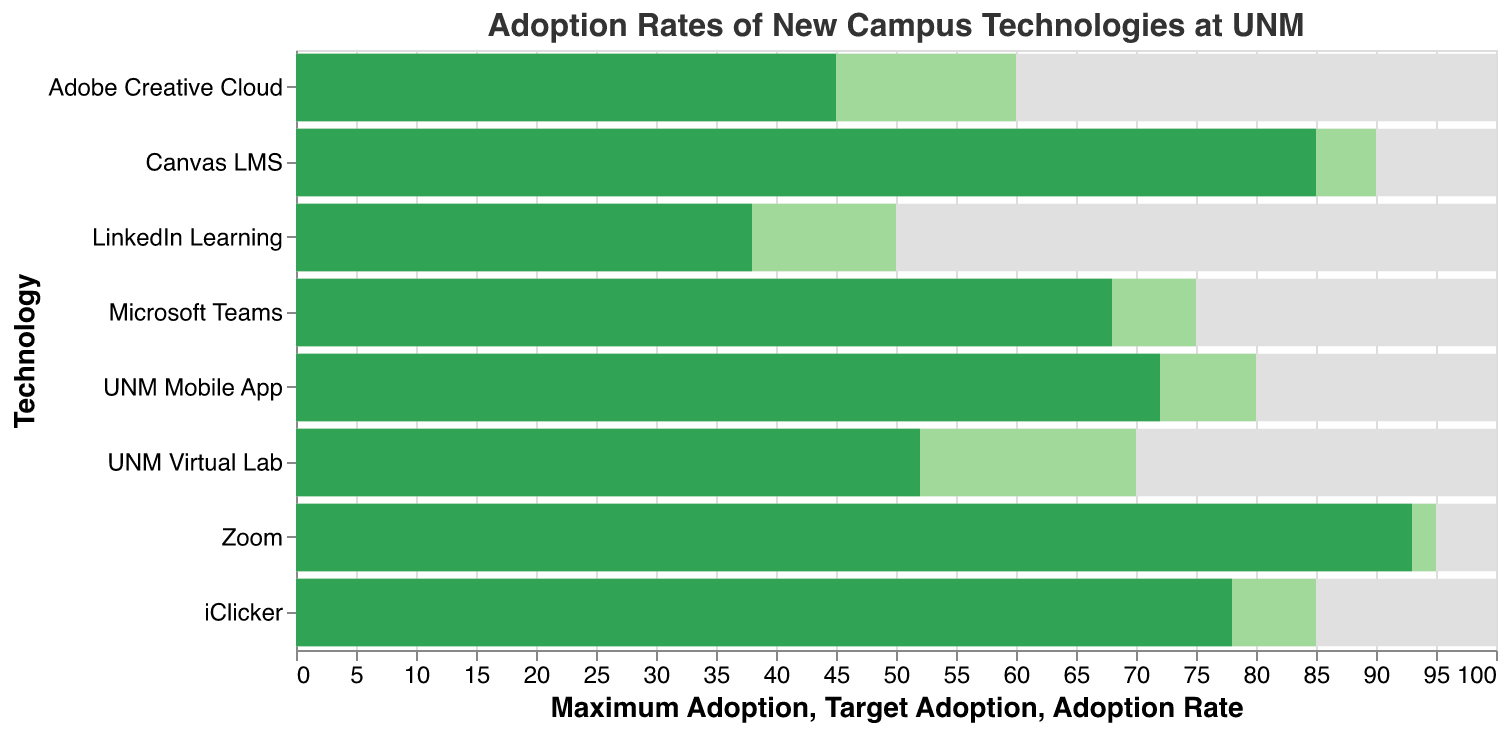What is the adoption rate of Canvas LMS? The figure shows the adoption rates for various campus technologies. The adoption rate for Canvas LMS is represented as one of the bars. By looking at the corresponding bar, we can see the value.
Answer: 85 Which technology has the highest adoption rate? The highest adoption rate can be identified by looking for the tallest green bar in the chart. Zoom has the tallest bar with an adoption rate of 93.
Answer: Zoom What is the target adoption rate for Adobe Creative Cloud? The figure includes target adoption rates, which are represented by light green bars. By locating Adobe Creative Cloud and finding the corresponding light green bar, we can see the target adoption rate.
Answer: 60 How many technologies have a target adoption rate greater than 70%? To find this, we count the number of light green bars that surpass the 70% mark. The technologies that meet this criterion are Canvas LMS, UNM Mobile App, Zoom, and iClicker.
Answer: 4 What is the difference between the maximum adoption and the current adoption rate for UNM Mobile App? The maximum adoption is 100 and the current adoption rate is 72. The difference can be calculated by subtracting 72 from 100.
Answer: 28 Which technology is closest to meeting its target adoption rate? To determine this, we look for the smallest difference between the current adoption rate and the target adoption rate. For Zoom, the difference is the smallest, with just a 2% difference (93 current vs 95 target).
Answer: Zoom What is the average adoption rate of all the technologies? To find the average, we sum the adoption rates of all technologies and divide by the number of technologies. The sum is 531 (85 + 72 + 68 + 45 + 93 + 38 + 78 + 52) and there are 8 technologies. The calculation is 531/8.
Answer: 66.38 How much does the current adoption of iClicker exceed that of LinkedIn Learning? The adoption rate for iClicker is 78 and for LinkedIn Learning it is 38. Subtracting LinkedIn Learning's rate from iClicker's rate gives us the difference.
Answer: 40 Which technology has the lowest adoption rate? By looking at the shortest green bar, we can identify LinkedIn Learning as having the lowest adoption rate.
Answer: LinkedIn Learning Are there any technologies that have already exceeded their target adoption rates? By comparing the green bars (current adoption) to the light green bars (target adoption), we can see that Zoom and Canvas LMS have adoption rates that exceed their respective target rates.
Answer: Yes 